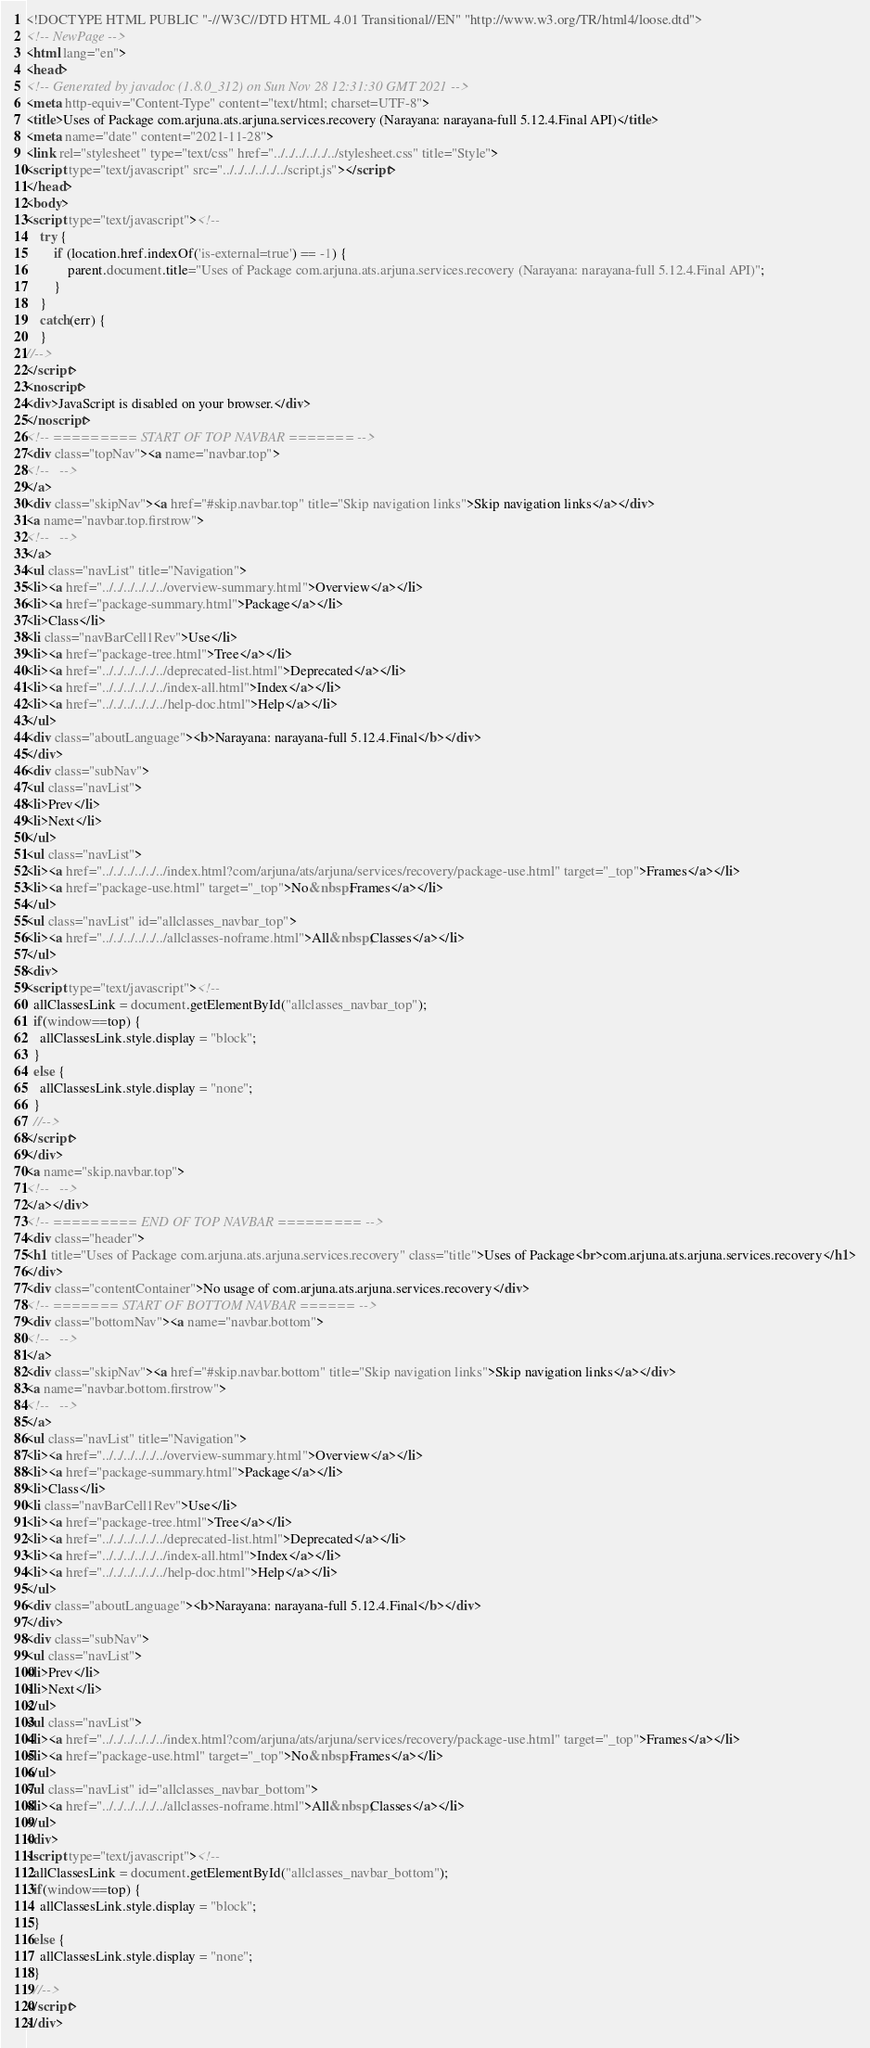<code> <loc_0><loc_0><loc_500><loc_500><_HTML_><!DOCTYPE HTML PUBLIC "-//W3C//DTD HTML 4.01 Transitional//EN" "http://www.w3.org/TR/html4/loose.dtd">
<!-- NewPage -->
<html lang="en">
<head>
<!-- Generated by javadoc (1.8.0_312) on Sun Nov 28 12:31:30 GMT 2021 -->
<meta http-equiv="Content-Type" content="text/html; charset=UTF-8">
<title>Uses of Package com.arjuna.ats.arjuna.services.recovery (Narayana: narayana-full 5.12.4.Final API)</title>
<meta name="date" content="2021-11-28">
<link rel="stylesheet" type="text/css" href="../../../../../../stylesheet.css" title="Style">
<script type="text/javascript" src="../../../../../../script.js"></script>
</head>
<body>
<script type="text/javascript"><!--
    try {
        if (location.href.indexOf('is-external=true') == -1) {
            parent.document.title="Uses of Package com.arjuna.ats.arjuna.services.recovery (Narayana: narayana-full 5.12.4.Final API)";
        }
    }
    catch(err) {
    }
//-->
</script>
<noscript>
<div>JavaScript is disabled on your browser.</div>
</noscript>
<!-- ========= START OF TOP NAVBAR ======= -->
<div class="topNav"><a name="navbar.top">
<!--   -->
</a>
<div class="skipNav"><a href="#skip.navbar.top" title="Skip navigation links">Skip navigation links</a></div>
<a name="navbar.top.firstrow">
<!--   -->
</a>
<ul class="navList" title="Navigation">
<li><a href="../../../../../../overview-summary.html">Overview</a></li>
<li><a href="package-summary.html">Package</a></li>
<li>Class</li>
<li class="navBarCell1Rev">Use</li>
<li><a href="package-tree.html">Tree</a></li>
<li><a href="../../../../../../deprecated-list.html">Deprecated</a></li>
<li><a href="../../../../../../index-all.html">Index</a></li>
<li><a href="../../../../../../help-doc.html">Help</a></li>
</ul>
<div class="aboutLanguage"><b>Narayana: narayana-full 5.12.4.Final</b></div>
</div>
<div class="subNav">
<ul class="navList">
<li>Prev</li>
<li>Next</li>
</ul>
<ul class="navList">
<li><a href="../../../../../../index.html?com/arjuna/ats/arjuna/services/recovery/package-use.html" target="_top">Frames</a></li>
<li><a href="package-use.html" target="_top">No&nbsp;Frames</a></li>
</ul>
<ul class="navList" id="allclasses_navbar_top">
<li><a href="../../../../../../allclasses-noframe.html">All&nbsp;Classes</a></li>
</ul>
<div>
<script type="text/javascript"><!--
  allClassesLink = document.getElementById("allclasses_navbar_top");
  if(window==top) {
    allClassesLink.style.display = "block";
  }
  else {
    allClassesLink.style.display = "none";
  }
  //-->
</script>
</div>
<a name="skip.navbar.top">
<!--   -->
</a></div>
<!-- ========= END OF TOP NAVBAR ========= -->
<div class="header">
<h1 title="Uses of Package com.arjuna.ats.arjuna.services.recovery" class="title">Uses of Package<br>com.arjuna.ats.arjuna.services.recovery</h1>
</div>
<div class="contentContainer">No usage of com.arjuna.ats.arjuna.services.recovery</div>
<!-- ======= START OF BOTTOM NAVBAR ====== -->
<div class="bottomNav"><a name="navbar.bottom">
<!--   -->
</a>
<div class="skipNav"><a href="#skip.navbar.bottom" title="Skip navigation links">Skip navigation links</a></div>
<a name="navbar.bottom.firstrow">
<!--   -->
</a>
<ul class="navList" title="Navigation">
<li><a href="../../../../../../overview-summary.html">Overview</a></li>
<li><a href="package-summary.html">Package</a></li>
<li>Class</li>
<li class="navBarCell1Rev">Use</li>
<li><a href="package-tree.html">Tree</a></li>
<li><a href="../../../../../../deprecated-list.html">Deprecated</a></li>
<li><a href="../../../../../../index-all.html">Index</a></li>
<li><a href="../../../../../../help-doc.html">Help</a></li>
</ul>
<div class="aboutLanguage"><b>Narayana: narayana-full 5.12.4.Final</b></div>
</div>
<div class="subNav">
<ul class="navList">
<li>Prev</li>
<li>Next</li>
</ul>
<ul class="navList">
<li><a href="../../../../../../index.html?com/arjuna/ats/arjuna/services/recovery/package-use.html" target="_top">Frames</a></li>
<li><a href="package-use.html" target="_top">No&nbsp;Frames</a></li>
</ul>
<ul class="navList" id="allclasses_navbar_bottom">
<li><a href="../../../../../../allclasses-noframe.html">All&nbsp;Classes</a></li>
</ul>
<div>
<script type="text/javascript"><!--
  allClassesLink = document.getElementById("allclasses_navbar_bottom");
  if(window==top) {
    allClassesLink.style.display = "block";
  }
  else {
    allClassesLink.style.display = "none";
  }
  //-->
</script>
</div></code> 